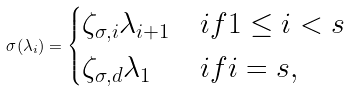Convert formula to latex. <formula><loc_0><loc_0><loc_500><loc_500>\sigma ( \lambda _ { i } ) = \begin{cases} \zeta _ { \sigma , i } \lambda _ { i + 1 } & i f 1 \leq i < { s } \\ \zeta _ { \sigma , d } \lambda _ { 1 } & i f i = { s } , \end{cases}</formula> 